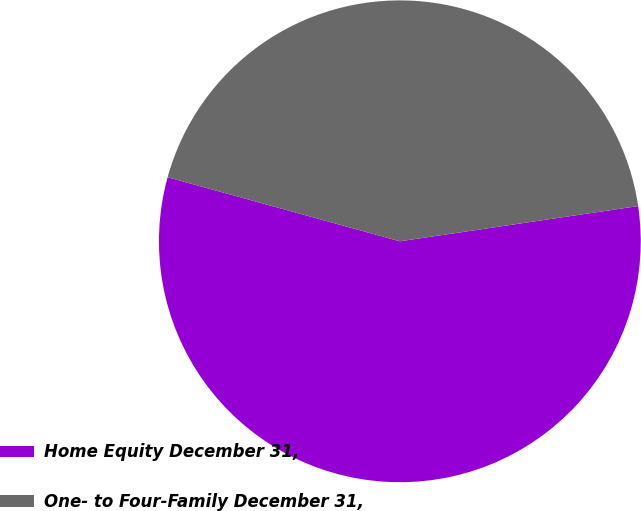<chart> <loc_0><loc_0><loc_500><loc_500><pie_chart><fcel>Home Equity December 31,<fcel>One- to Four-Family December 31,<nl><fcel>56.62%<fcel>43.38%<nl></chart> 